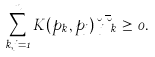<formula> <loc_0><loc_0><loc_500><loc_500>\sum _ { k , j = 1 } ^ { n } K ( p _ { k } , p _ { j } ) \lambda _ { j } \overline { \lambda } _ { k } \geq 0 .</formula> 